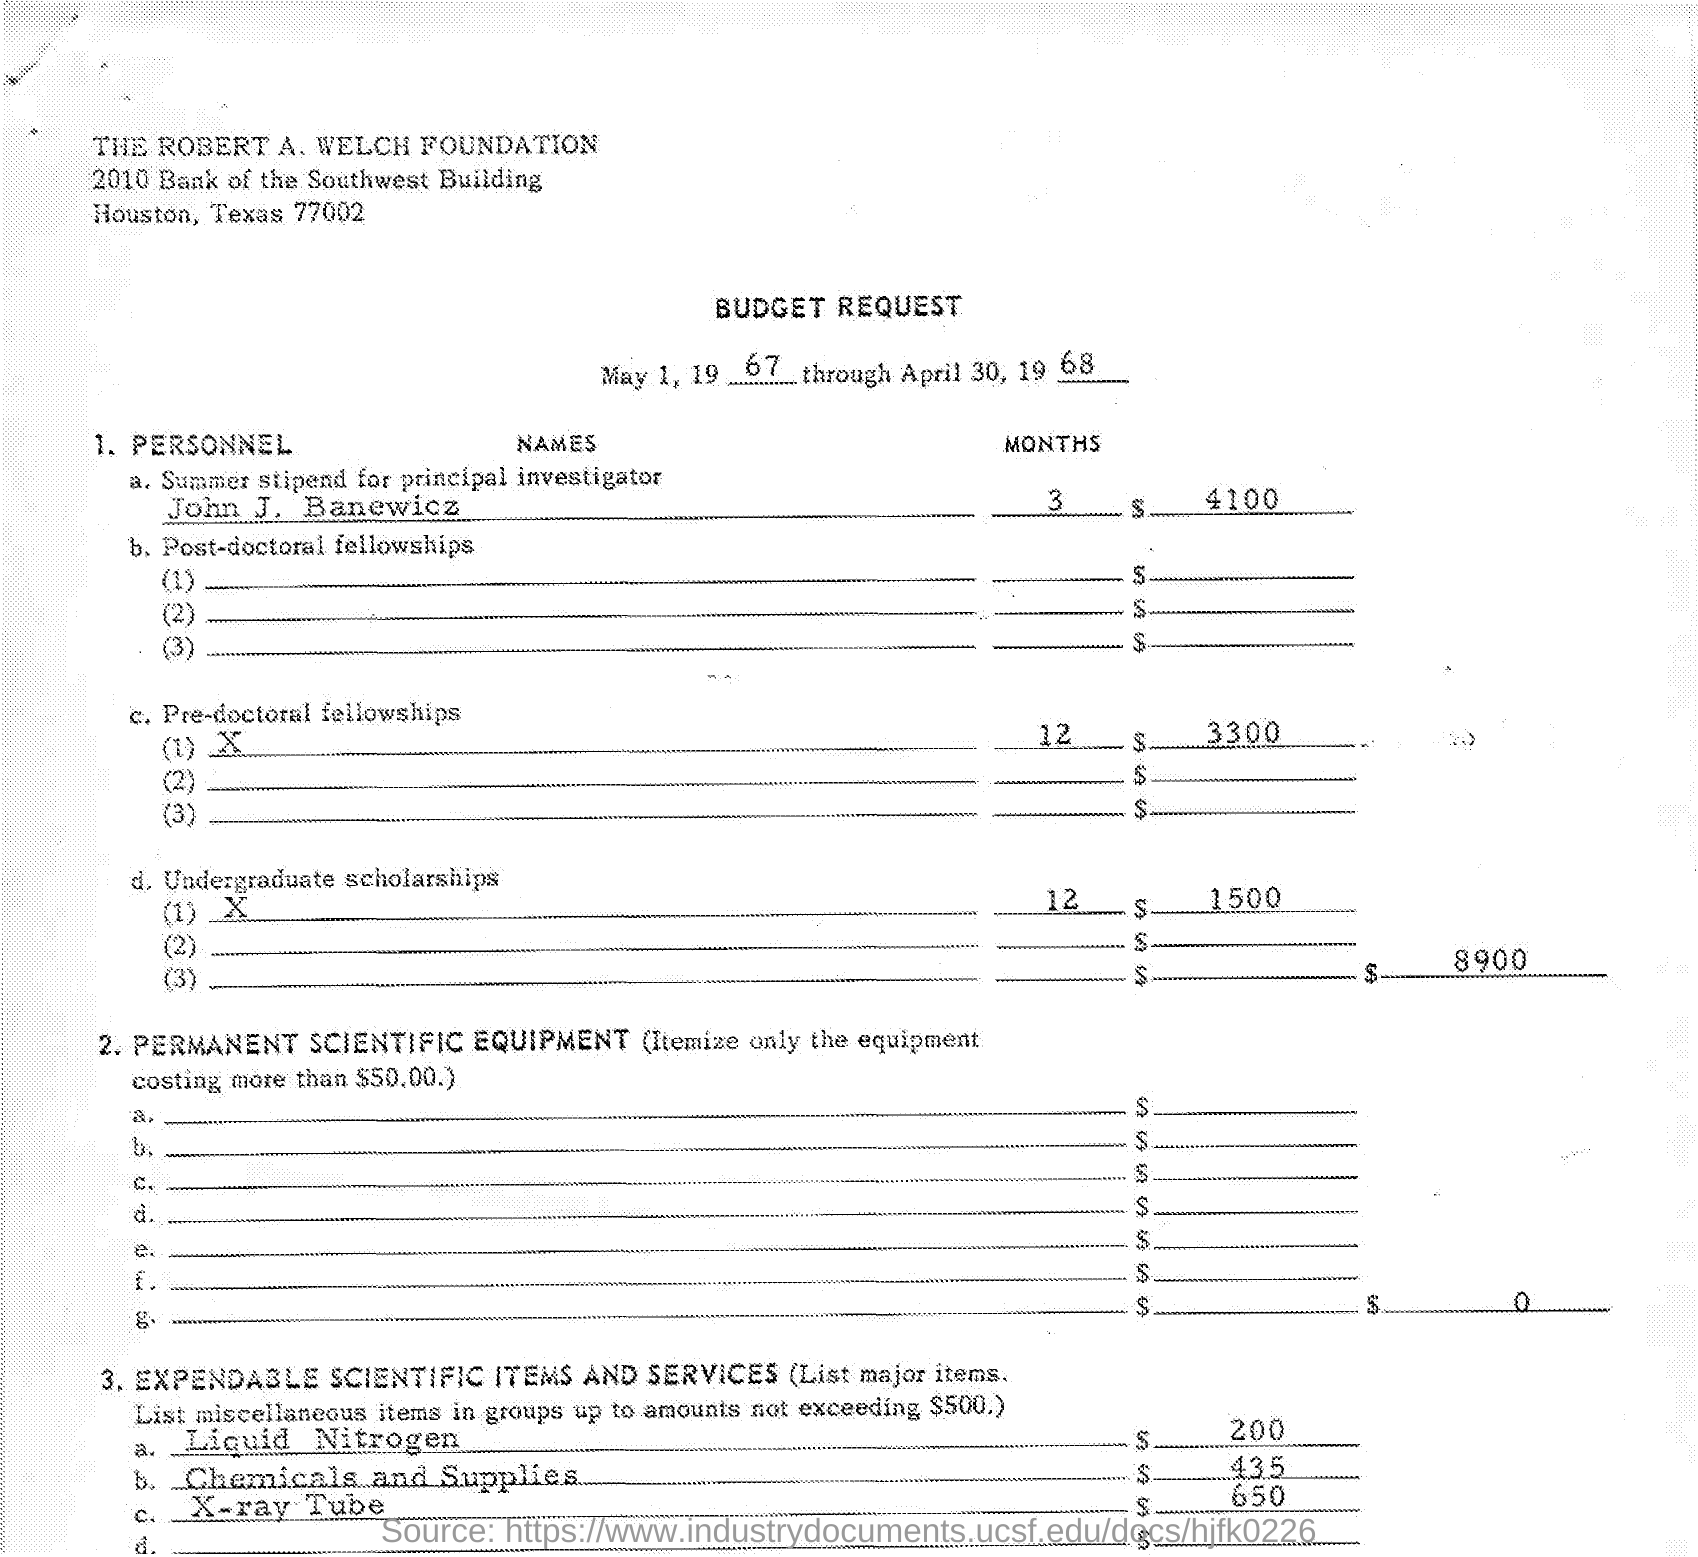What is the Title of the document?
Make the answer very short. BUDGET REQUEST. What is the date on the document?
Your answer should be very brief. MAY 1, 1967 THROUGH APRIL 30, 1968. Who is the Principal Investigator?
Ensure brevity in your answer.  John J. Banewicz. What is the Summer stipend for John J. Banewicz?
Provide a succinct answer. $4100. What is the cost for Liquid Nitrogen?
Offer a very short reply. $200. What is the cost for Chemicals and Supplies?
Offer a very short reply. $435. 